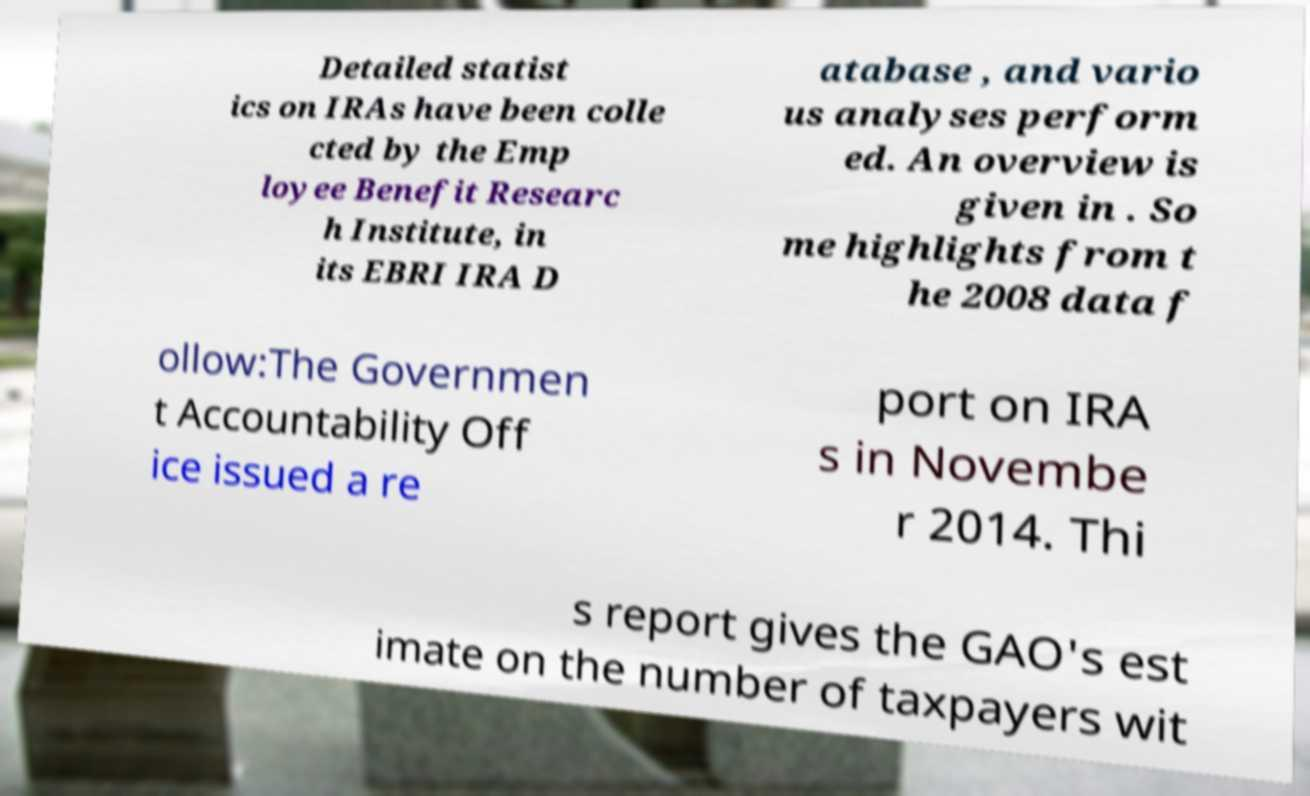Could you extract and type out the text from this image? Detailed statist ics on IRAs have been colle cted by the Emp loyee Benefit Researc h Institute, in its EBRI IRA D atabase , and vario us analyses perform ed. An overview is given in . So me highlights from t he 2008 data f ollow:The Governmen t Accountability Off ice issued a re port on IRA s in Novembe r 2014. Thi s report gives the GAO's est imate on the number of taxpayers wit 